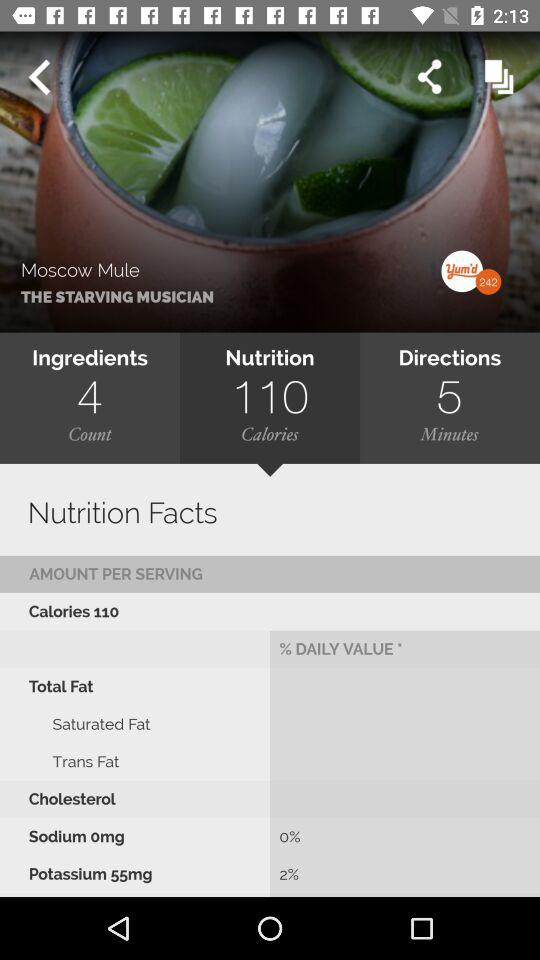What is the name of the cocktail? The name of the cocktail is "Moscow Mule". 